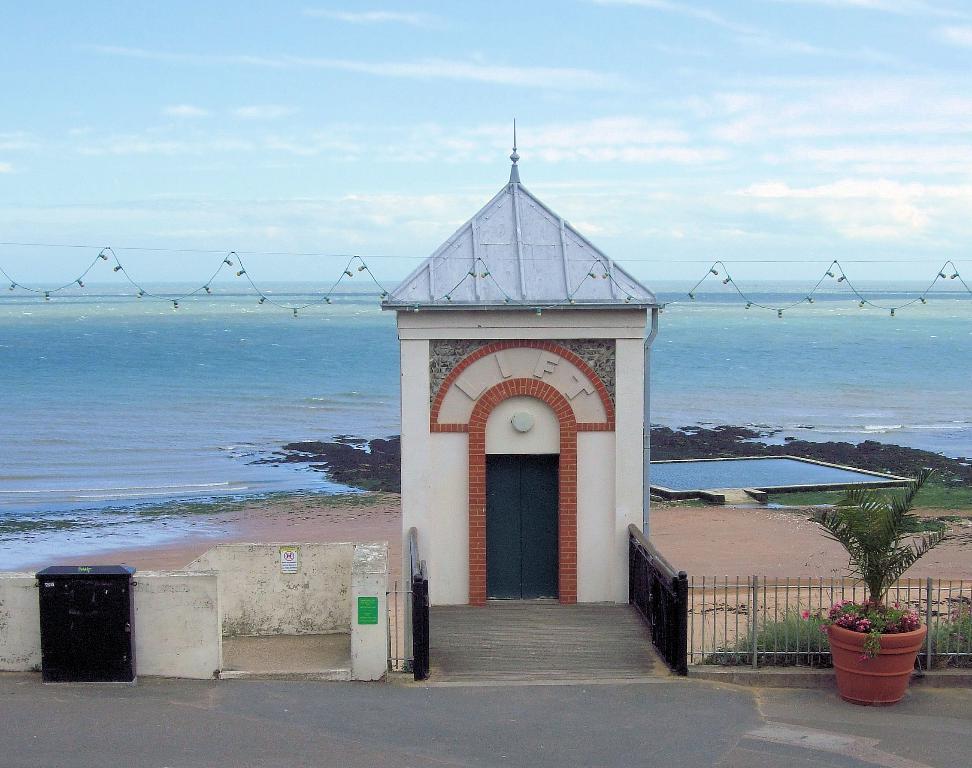Could you give a brief overview of what you see in this image? In this picture we can see a lift in the middle, on the right side there are some plants, we can see a box on the left side, in the background there is water, we can see the sky at the top of the picture, there are some serial lights in the middle, on the right side there is grass. 